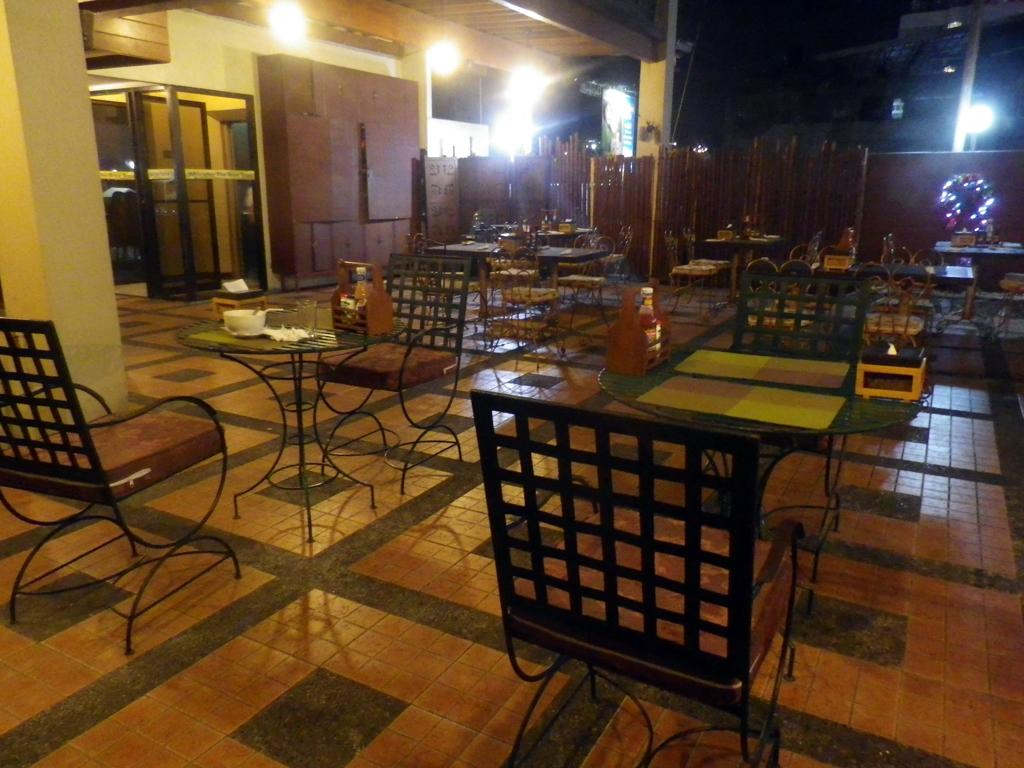What type of furniture is present in the image? There are tables and chairs in the image. What can be used for illumination in the image? There are lights visible in the image. What architectural feature is on the left side of the image? There is a pillar on the left side of the image. How would you describe the overall lighting in the image? The background of the image is dark. What riddle is being solved by the team in the image? There is no team or riddle present in the image; it only features tables, chairs, lights, a pillar, and a dark background. 